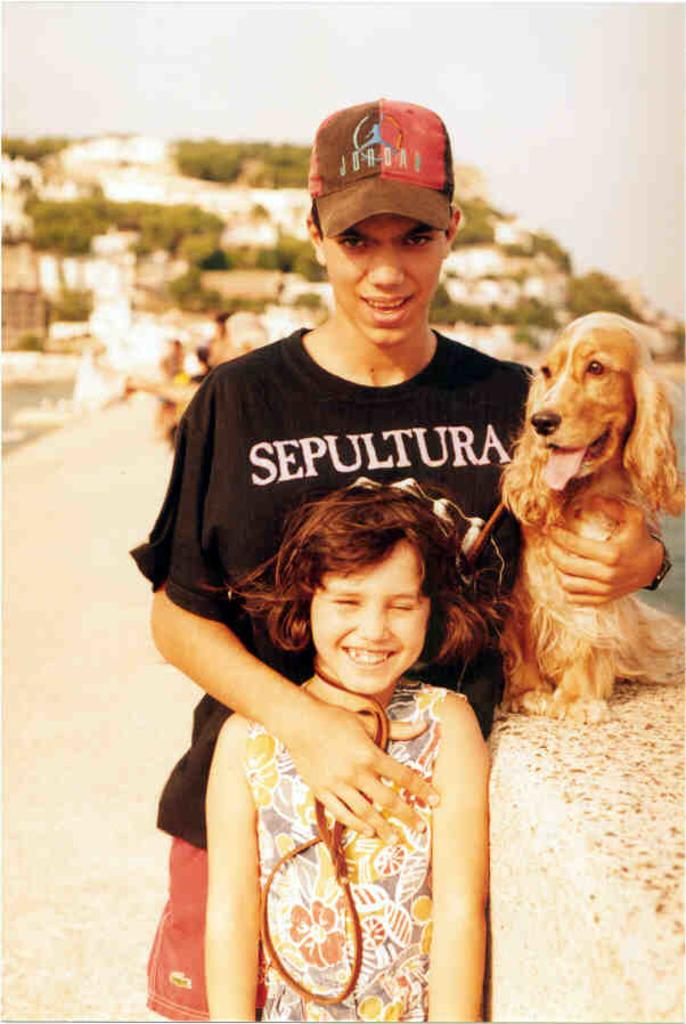What is the main subject of the image? There is a person in the image. What is the person wearing? The person is wearing a black shirt. What is the person doing with their hand? The person is holding a dog with one hand and has another hand placed on a kid in front of them. Where is the person's hand holding the dog? The hand holding the dog is on a wall. What type of veil is the person wearing in the image? There is no veil present in the image; the person is wearing a black shirt. Is the person undergoing a scarf-related operation in the image? There is no operation or scarf mentioned in the image; the person is holding a dog and interacting with a kid. 